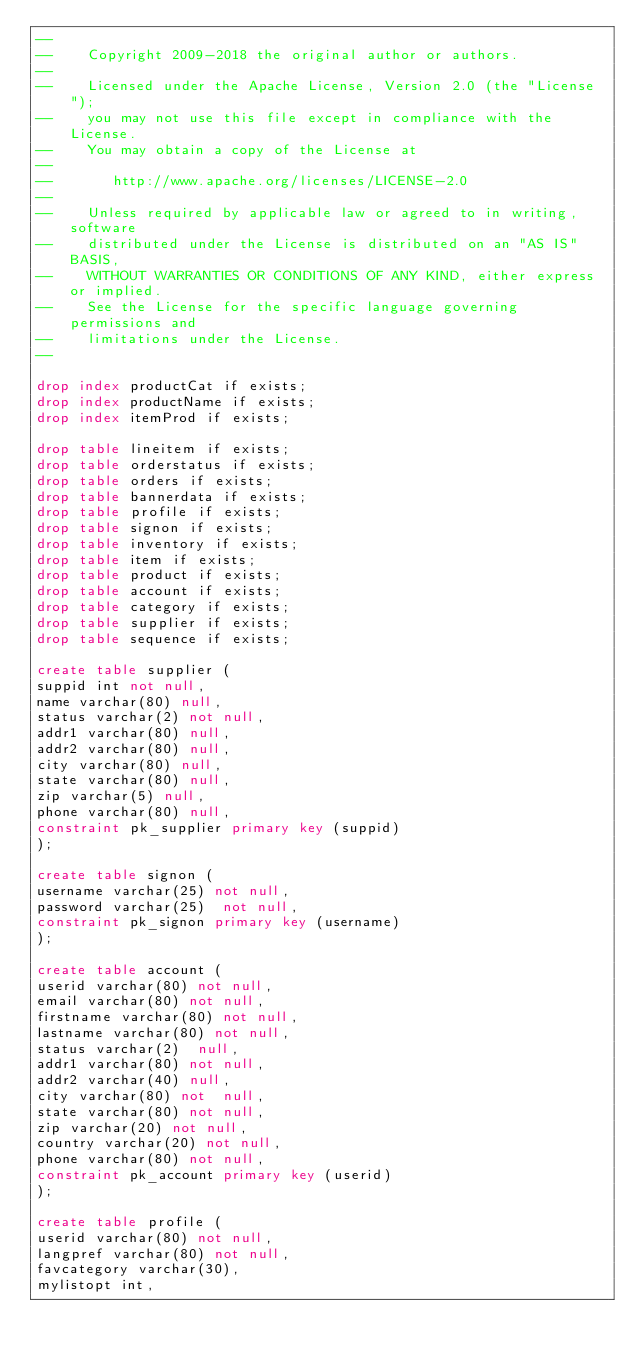Convert code to text. <code><loc_0><loc_0><loc_500><loc_500><_SQL_>--
--    Copyright 2009-2018 the original author or authors.
--
--    Licensed under the Apache License, Version 2.0 (the "License");
--    you may not use this file except in compliance with the License.
--    You may obtain a copy of the License at
--
--       http://www.apache.org/licenses/LICENSE-2.0
--
--    Unless required by applicable law or agreed to in writing, software
--    distributed under the License is distributed on an "AS IS" BASIS,
--    WITHOUT WARRANTIES OR CONDITIONS OF ANY KIND, either express or implied.
--    See the License for the specific language governing permissions and
--    limitations under the License.
--

drop index productCat if exists;
drop index productName if exists;
drop index itemProd if exists;

drop table lineitem if exists;
drop table orderstatus if exists;
drop table orders if exists;
drop table bannerdata if exists;
drop table profile if exists;
drop table signon if exists;
drop table inventory if exists;
drop table item if exists;
drop table product if exists;
drop table account if exists;
drop table category if exists;
drop table supplier if exists;
drop table sequence if exists;

create table supplier (
suppid int not null,
name varchar(80) null,
status varchar(2) not null,
addr1 varchar(80) null,
addr2 varchar(80) null,
city varchar(80) null,
state varchar(80) null,
zip varchar(5) null,
phone varchar(80) null,
constraint pk_supplier primary key (suppid)
);

create table signon (
username varchar(25) not null,
password varchar(25)  not null,
constraint pk_signon primary key (username)
);

create table account (
userid varchar(80) not null,
email varchar(80) not null,
firstname varchar(80) not null,
lastname varchar(80) not null,
status varchar(2)  null,
addr1 varchar(80) not null,
addr2 varchar(40) null,
city varchar(80) not  null,
state varchar(80) not null,
zip varchar(20) not null,
country varchar(20) not null,
phone varchar(80) not null,
constraint pk_account primary key (userid)
);

create table profile (
userid varchar(80) not null,
langpref varchar(80) not null,
favcategory varchar(30),
mylistopt int,</code> 